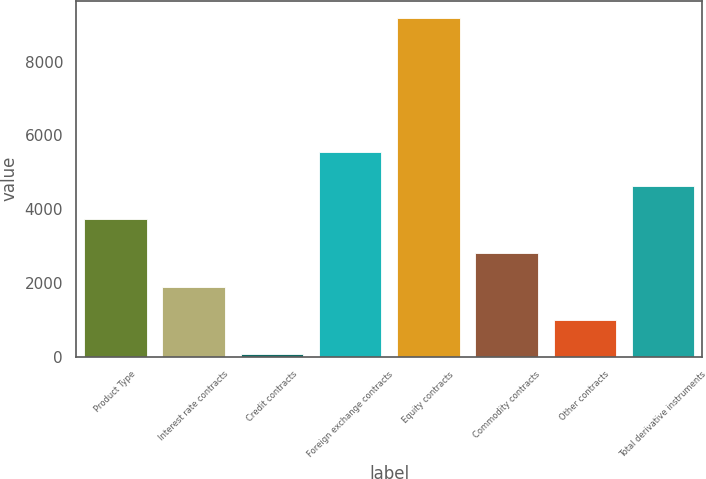Convert chart to OTSL. <chart><loc_0><loc_0><loc_500><loc_500><bar_chart><fcel>Product Type<fcel>Interest rate contracts<fcel>Credit contracts<fcel>Foreign exchange contracts<fcel>Equity contracts<fcel>Commodity contracts<fcel>Other contracts<fcel>Total derivative instruments<nl><fcel>3721.6<fcel>1897.8<fcel>74<fcel>5545.4<fcel>9193<fcel>2809.7<fcel>985.9<fcel>4633.5<nl></chart> 